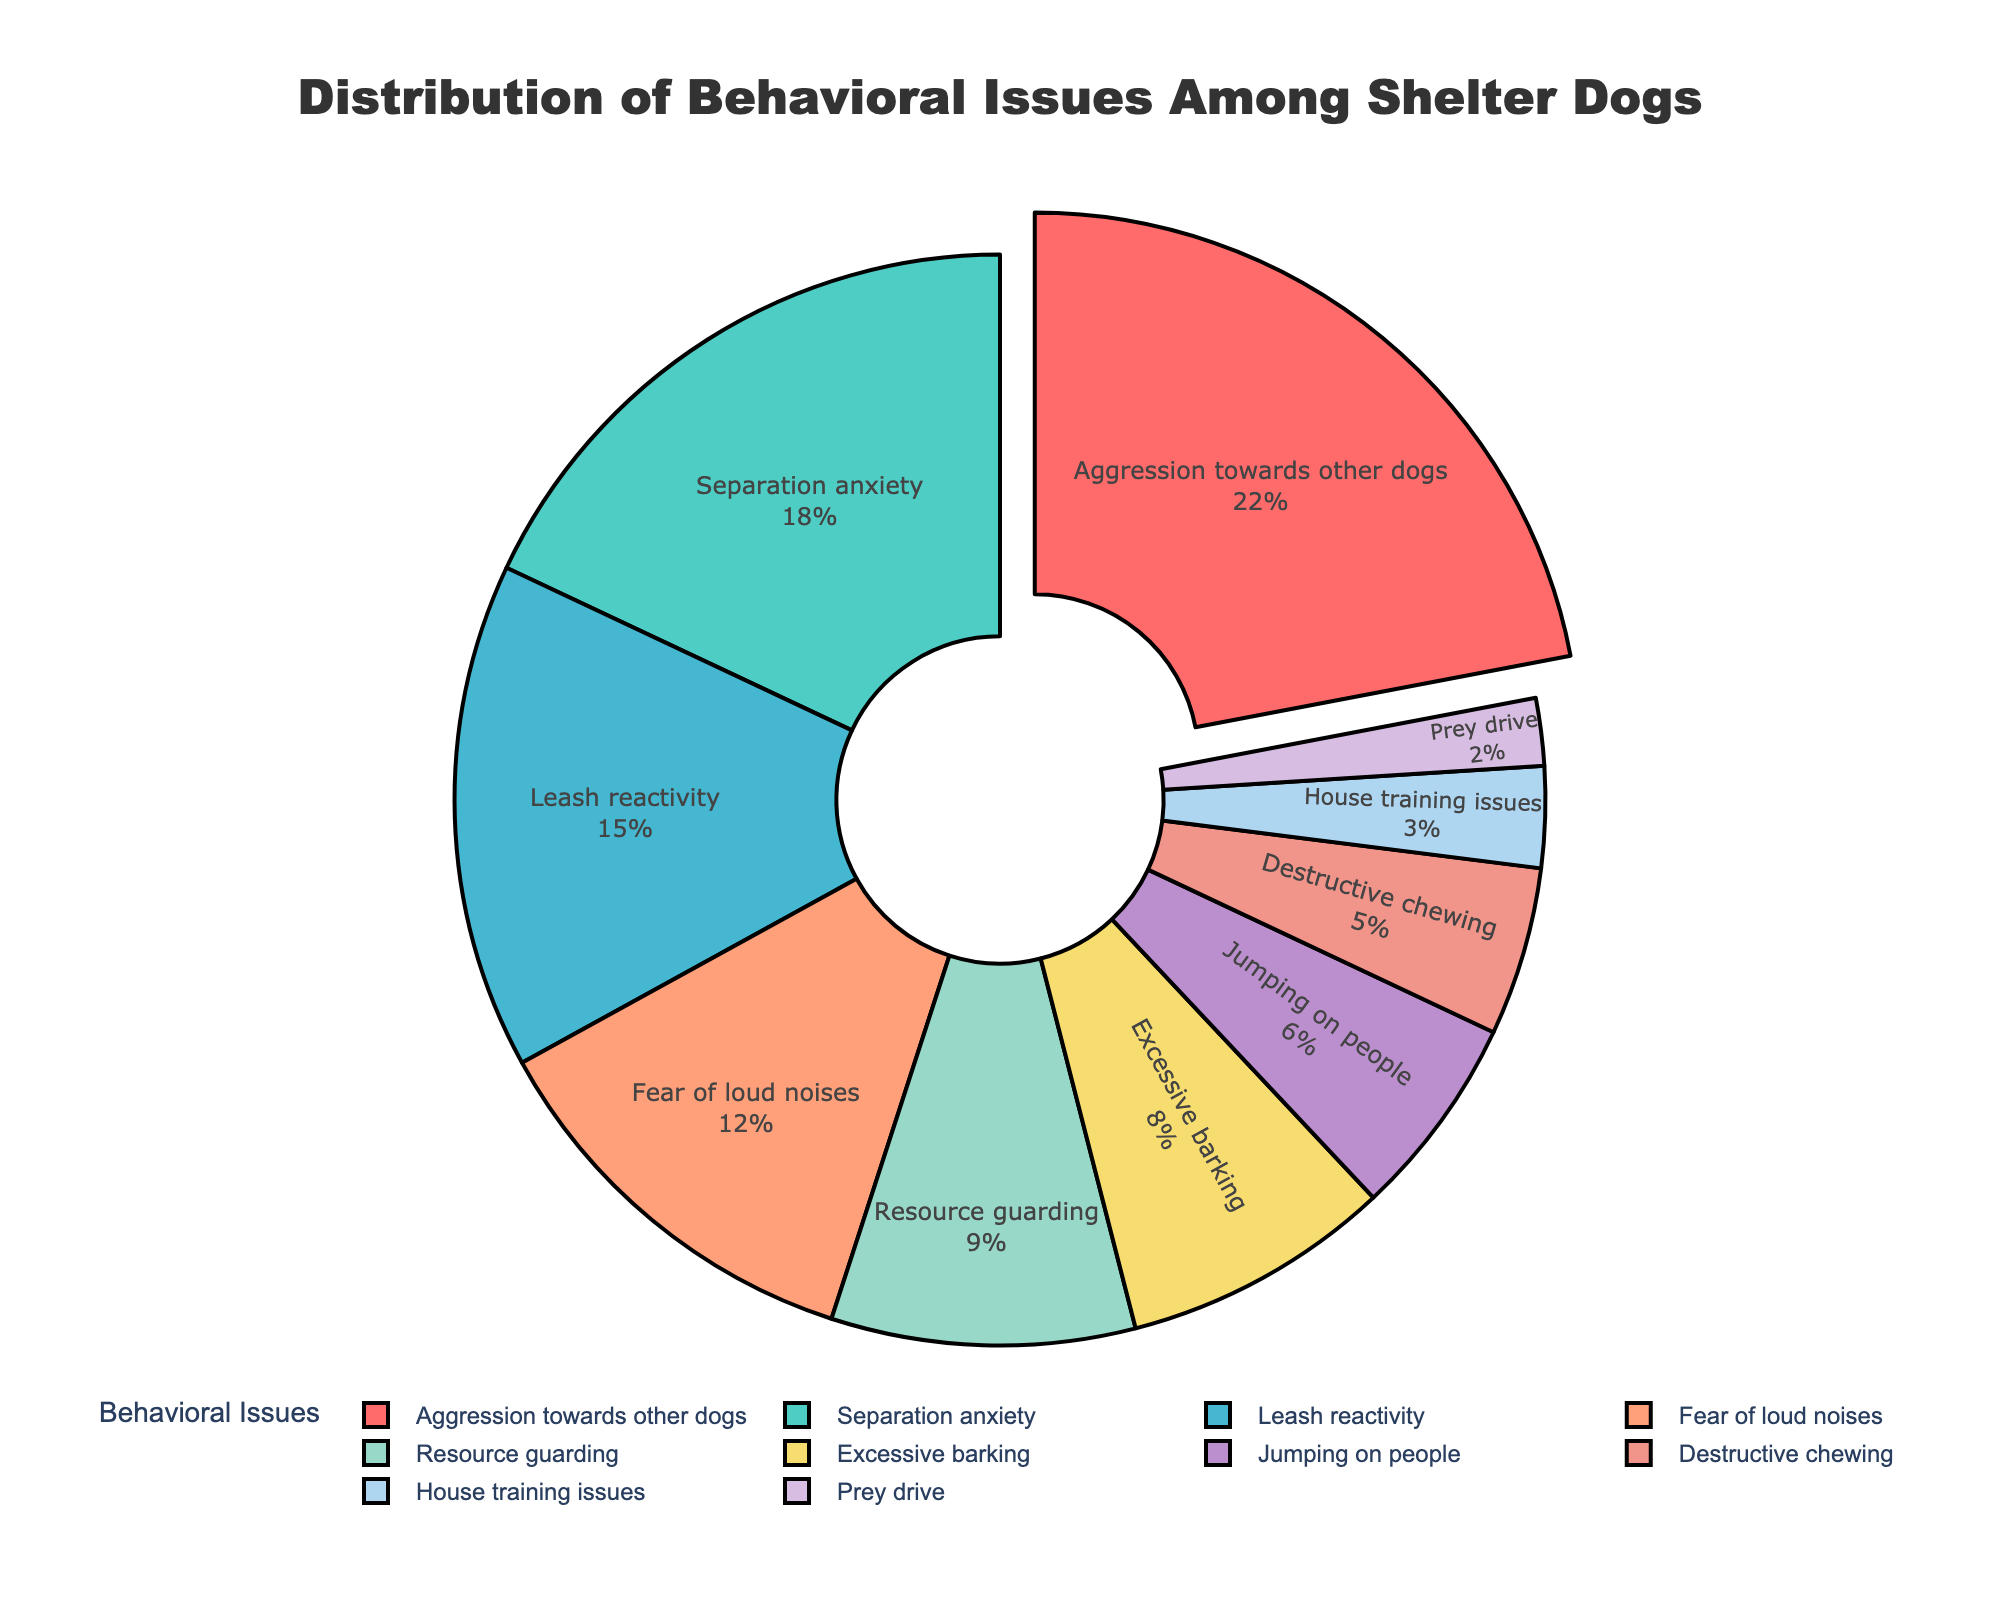What is the most common behavioral issue among shelter dogs? The figure highlights the section with the highest percentage by pulling it out slightly from the rest of the pie chart. This section represents 'Aggression towards other dogs' with 22%.
Answer: Aggression towards other dogs What percentage of shelter dogs have separation anxiety and leash reactivity combined? To determine this, sum the percentages of the two categories: separation anxiety (18%) and leash reactivity (15%). 18 + 15 = 33%.
Answer: 33% Which behavioral issue is the least common among shelter dogs? The smallest segment of the pie chart represents the least common issue. It is labeled 'Prey drive' with a percentage of 2%.
Answer: Prey drive What is the difference in percentage between dogs with resource guarding issues and dogs with excessive barking issues? Subtract the percentage of dogs with excessive barking (8%) from the percentage of dogs with resource guarding (9%). 9 - 8 = 1%.
Answer: 1% What is the combined percentage of dogs with fear of loud noises, destructive chewing, and house training issues? Add the percentages of the three categories: fear of loud noises (12%), destructive chewing (5%), and house training issues (3%). 12 + 5 + 3 = 20%.
Answer: 20% How much higher is the percentage of dogs with leash reactivity compared to dogs with jumping on people issues? Subtract the percentage of dogs with jumping on people issues (6%) from the percentage of dogs with leash reactivity (15%). 15 - 6 = 9%.
Answer: 9% What color represents the segment for dogs with jumping on people issues? The segment for 'Jumping on people' is visually displayed in the color purple.
Answer: Purple Which behavioral issue is represented with the green color in the pie chart? The green section of the pie chart is labeled as 'Separation anxiety' with a percentage of 18%.
Answer: Separation anxiety Are there more dogs with leash reactivity issues or dogs with fear of loud noises? Compare the percentages of the two categories: leash reactivity (15%) and fear of loud noises (12%). 15% is greater than 12%.
Answer: Leash reactivity What percentage of behavioral issues in shelter dogs is related either to aggression towards other dogs or house training issues? Sum the percentages of 'Aggression towards other dogs' (22%) and 'House training issues' (3%). 22 + 3 = 25%.
Answer: 25% 